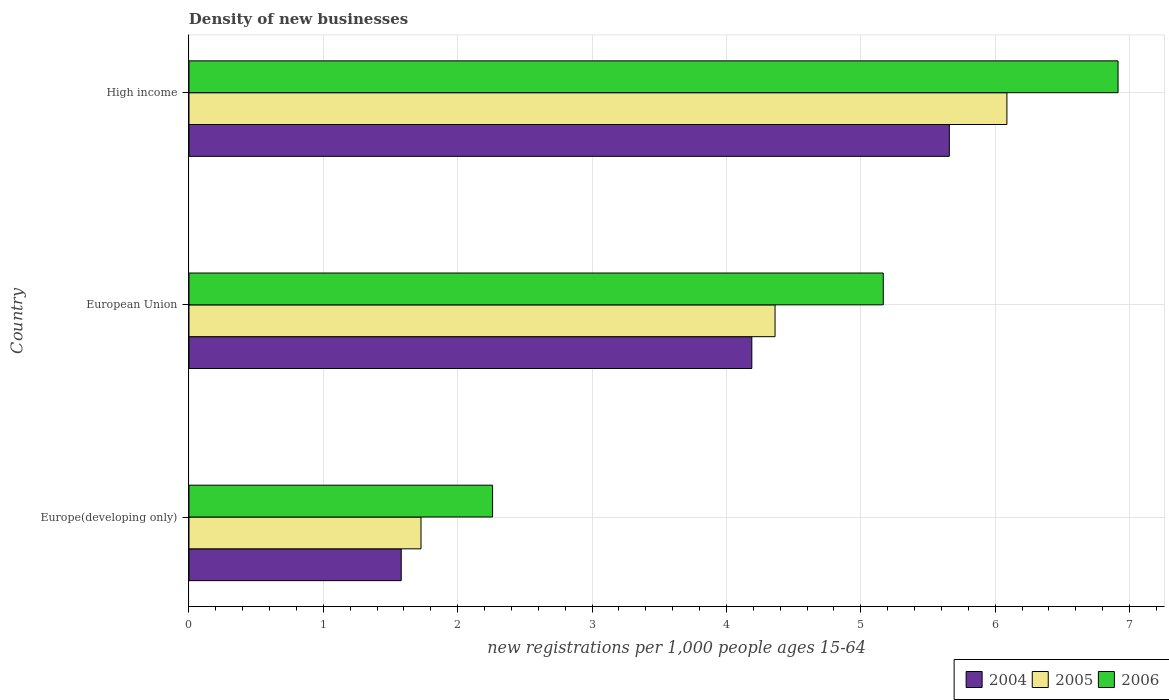How many groups of bars are there?
Provide a short and direct response. 3. Are the number of bars on each tick of the Y-axis equal?
Offer a terse response. Yes. How many bars are there on the 1st tick from the top?
Keep it short and to the point. 3. What is the label of the 2nd group of bars from the top?
Offer a terse response. European Union. In how many cases, is the number of bars for a given country not equal to the number of legend labels?
Ensure brevity in your answer.  0. What is the number of new registrations in 2004 in European Union?
Your response must be concise. 4.19. Across all countries, what is the maximum number of new registrations in 2004?
Your response must be concise. 5.66. Across all countries, what is the minimum number of new registrations in 2004?
Provide a succinct answer. 1.58. In which country was the number of new registrations in 2005 minimum?
Offer a very short reply. Europe(developing only). What is the total number of new registrations in 2004 in the graph?
Provide a succinct answer. 11.43. What is the difference between the number of new registrations in 2005 in European Union and that in High income?
Keep it short and to the point. -1.73. What is the difference between the number of new registrations in 2005 in Europe(developing only) and the number of new registrations in 2006 in High income?
Keep it short and to the point. -5.19. What is the average number of new registrations in 2005 per country?
Provide a succinct answer. 4.06. What is the difference between the number of new registrations in 2006 and number of new registrations in 2005 in High income?
Your response must be concise. 0.83. In how many countries, is the number of new registrations in 2006 greater than 2.8 ?
Provide a succinct answer. 2. What is the ratio of the number of new registrations in 2004 in European Union to that in High income?
Your answer should be compact. 0.74. Is the number of new registrations in 2005 in European Union less than that in High income?
Provide a short and direct response. Yes. What is the difference between the highest and the second highest number of new registrations in 2006?
Offer a terse response. 1.75. What is the difference between the highest and the lowest number of new registrations in 2005?
Offer a terse response. 4.36. In how many countries, is the number of new registrations in 2005 greater than the average number of new registrations in 2005 taken over all countries?
Keep it short and to the point. 2. How many bars are there?
Your response must be concise. 9. Are all the bars in the graph horizontal?
Ensure brevity in your answer.  Yes. How many countries are there in the graph?
Give a very brief answer. 3. Does the graph contain any zero values?
Ensure brevity in your answer.  No. Where does the legend appear in the graph?
Make the answer very short. Bottom right. How many legend labels are there?
Make the answer very short. 3. How are the legend labels stacked?
Keep it short and to the point. Horizontal. What is the title of the graph?
Your answer should be very brief. Density of new businesses. What is the label or title of the X-axis?
Your answer should be very brief. New registrations per 1,0 people ages 15-64. What is the label or title of the Y-axis?
Give a very brief answer. Country. What is the new registrations per 1,000 people ages 15-64 of 2004 in Europe(developing only)?
Ensure brevity in your answer.  1.58. What is the new registrations per 1,000 people ages 15-64 of 2005 in Europe(developing only)?
Offer a very short reply. 1.73. What is the new registrations per 1,000 people ages 15-64 of 2006 in Europe(developing only)?
Provide a short and direct response. 2.26. What is the new registrations per 1,000 people ages 15-64 in 2004 in European Union?
Give a very brief answer. 4.19. What is the new registrations per 1,000 people ages 15-64 in 2005 in European Union?
Ensure brevity in your answer.  4.36. What is the new registrations per 1,000 people ages 15-64 in 2006 in European Union?
Ensure brevity in your answer.  5.17. What is the new registrations per 1,000 people ages 15-64 in 2004 in High income?
Your answer should be very brief. 5.66. What is the new registrations per 1,000 people ages 15-64 of 2005 in High income?
Offer a very short reply. 6.09. What is the new registrations per 1,000 people ages 15-64 of 2006 in High income?
Your answer should be compact. 6.91. Across all countries, what is the maximum new registrations per 1,000 people ages 15-64 of 2004?
Offer a terse response. 5.66. Across all countries, what is the maximum new registrations per 1,000 people ages 15-64 in 2005?
Offer a very short reply. 6.09. Across all countries, what is the maximum new registrations per 1,000 people ages 15-64 of 2006?
Offer a terse response. 6.91. Across all countries, what is the minimum new registrations per 1,000 people ages 15-64 of 2004?
Offer a terse response. 1.58. Across all countries, what is the minimum new registrations per 1,000 people ages 15-64 of 2005?
Ensure brevity in your answer.  1.73. Across all countries, what is the minimum new registrations per 1,000 people ages 15-64 in 2006?
Ensure brevity in your answer.  2.26. What is the total new registrations per 1,000 people ages 15-64 of 2004 in the graph?
Give a very brief answer. 11.43. What is the total new registrations per 1,000 people ages 15-64 of 2005 in the graph?
Your answer should be very brief. 12.18. What is the total new registrations per 1,000 people ages 15-64 of 2006 in the graph?
Offer a very short reply. 14.34. What is the difference between the new registrations per 1,000 people ages 15-64 in 2004 in Europe(developing only) and that in European Union?
Ensure brevity in your answer.  -2.61. What is the difference between the new registrations per 1,000 people ages 15-64 in 2005 in Europe(developing only) and that in European Union?
Your answer should be compact. -2.64. What is the difference between the new registrations per 1,000 people ages 15-64 in 2006 in Europe(developing only) and that in European Union?
Your response must be concise. -2.91. What is the difference between the new registrations per 1,000 people ages 15-64 in 2004 in Europe(developing only) and that in High income?
Offer a terse response. -4.08. What is the difference between the new registrations per 1,000 people ages 15-64 of 2005 in Europe(developing only) and that in High income?
Keep it short and to the point. -4.36. What is the difference between the new registrations per 1,000 people ages 15-64 of 2006 in Europe(developing only) and that in High income?
Provide a short and direct response. -4.66. What is the difference between the new registrations per 1,000 people ages 15-64 in 2004 in European Union and that in High income?
Offer a very short reply. -1.47. What is the difference between the new registrations per 1,000 people ages 15-64 of 2005 in European Union and that in High income?
Your answer should be compact. -1.73. What is the difference between the new registrations per 1,000 people ages 15-64 of 2006 in European Union and that in High income?
Your answer should be compact. -1.75. What is the difference between the new registrations per 1,000 people ages 15-64 of 2004 in Europe(developing only) and the new registrations per 1,000 people ages 15-64 of 2005 in European Union?
Keep it short and to the point. -2.78. What is the difference between the new registrations per 1,000 people ages 15-64 in 2004 in Europe(developing only) and the new registrations per 1,000 people ages 15-64 in 2006 in European Union?
Your response must be concise. -3.59. What is the difference between the new registrations per 1,000 people ages 15-64 of 2005 in Europe(developing only) and the new registrations per 1,000 people ages 15-64 of 2006 in European Union?
Make the answer very short. -3.44. What is the difference between the new registrations per 1,000 people ages 15-64 in 2004 in Europe(developing only) and the new registrations per 1,000 people ages 15-64 in 2005 in High income?
Your answer should be compact. -4.51. What is the difference between the new registrations per 1,000 people ages 15-64 of 2004 in Europe(developing only) and the new registrations per 1,000 people ages 15-64 of 2006 in High income?
Ensure brevity in your answer.  -5.33. What is the difference between the new registrations per 1,000 people ages 15-64 of 2005 in Europe(developing only) and the new registrations per 1,000 people ages 15-64 of 2006 in High income?
Your answer should be very brief. -5.19. What is the difference between the new registrations per 1,000 people ages 15-64 in 2004 in European Union and the new registrations per 1,000 people ages 15-64 in 2005 in High income?
Offer a terse response. -1.9. What is the difference between the new registrations per 1,000 people ages 15-64 in 2004 in European Union and the new registrations per 1,000 people ages 15-64 in 2006 in High income?
Ensure brevity in your answer.  -2.73. What is the difference between the new registrations per 1,000 people ages 15-64 of 2005 in European Union and the new registrations per 1,000 people ages 15-64 of 2006 in High income?
Provide a short and direct response. -2.55. What is the average new registrations per 1,000 people ages 15-64 in 2004 per country?
Offer a terse response. 3.81. What is the average new registrations per 1,000 people ages 15-64 in 2005 per country?
Your answer should be compact. 4.06. What is the average new registrations per 1,000 people ages 15-64 in 2006 per country?
Offer a terse response. 4.78. What is the difference between the new registrations per 1,000 people ages 15-64 of 2004 and new registrations per 1,000 people ages 15-64 of 2005 in Europe(developing only)?
Provide a succinct answer. -0.15. What is the difference between the new registrations per 1,000 people ages 15-64 in 2004 and new registrations per 1,000 people ages 15-64 in 2006 in Europe(developing only)?
Make the answer very short. -0.68. What is the difference between the new registrations per 1,000 people ages 15-64 of 2005 and new registrations per 1,000 people ages 15-64 of 2006 in Europe(developing only)?
Provide a short and direct response. -0.53. What is the difference between the new registrations per 1,000 people ages 15-64 of 2004 and new registrations per 1,000 people ages 15-64 of 2005 in European Union?
Offer a very short reply. -0.17. What is the difference between the new registrations per 1,000 people ages 15-64 in 2004 and new registrations per 1,000 people ages 15-64 in 2006 in European Union?
Make the answer very short. -0.98. What is the difference between the new registrations per 1,000 people ages 15-64 of 2005 and new registrations per 1,000 people ages 15-64 of 2006 in European Union?
Give a very brief answer. -0.81. What is the difference between the new registrations per 1,000 people ages 15-64 in 2004 and new registrations per 1,000 people ages 15-64 in 2005 in High income?
Provide a short and direct response. -0.43. What is the difference between the new registrations per 1,000 people ages 15-64 of 2004 and new registrations per 1,000 people ages 15-64 of 2006 in High income?
Give a very brief answer. -1.26. What is the difference between the new registrations per 1,000 people ages 15-64 of 2005 and new registrations per 1,000 people ages 15-64 of 2006 in High income?
Provide a short and direct response. -0.83. What is the ratio of the new registrations per 1,000 people ages 15-64 of 2004 in Europe(developing only) to that in European Union?
Keep it short and to the point. 0.38. What is the ratio of the new registrations per 1,000 people ages 15-64 in 2005 in Europe(developing only) to that in European Union?
Your answer should be very brief. 0.4. What is the ratio of the new registrations per 1,000 people ages 15-64 of 2006 in Europe(developing only) to that in European Union?
Your answer should be very brief. 0.44. What is the ratio of the new registrations per 1,000 people ages 15-64 in 2004 in Europe(developing only) to that in High income?
Your answer should be compact. 0.28. What is the ratio of the new registrations per 1,000 people ages 15-64 of 2005 in Europe(developing only) to that in High income?
Offer a very short reply. 0.28. What is the ratio of the new registrations per 1,000 people ages 15-64 in 2006 in Europe(developing only) to that in High income?
Offer a terse response. 0.33. What is the ratio of the new registrations per 1,000 people ages 15-64 of 2004 in European Union to that in High income?
Keep it short and to the point. 0.74. What is the ratio of the new registrations per 1,000 people ages 15-64 of 2005 in European Union to that in High income?
Keep it short and to the point. 0.72. What is the ratio of the new registrations per 1,000 people ages 15-64 of 2006 in European Union to that in High income?
Make the answer very short. 0.75. What is the difference between the highest and the second highest new registrations per 1,000 people ages 15-64 in 2004?
Offer a terse response. 1.47. What is the difference between the highest and the second highest new registrations per 1,000 people ages 15-64 of 2005?
Provide a short and direct response. 1.73. What is the difference between the highest and the second highest new registrations per 1,000 people ages 15-64 in 2006?
Offer a very short reply. 1.75. What is the difference between the highest and the lowest new registrations per 1,000 people ages 15-64 in 2004?
Your answer should be very brief. 4.08. What is the difference between the highest and the lowest new registrations per 1,000 people ages 15-64 in 2005?
Your answer should be compact. 4.36. What is the difference between the highest and the lowest new registrations per 1,000 people ages 15-64 of 2006?
Offer a very short reply. 4.66. 